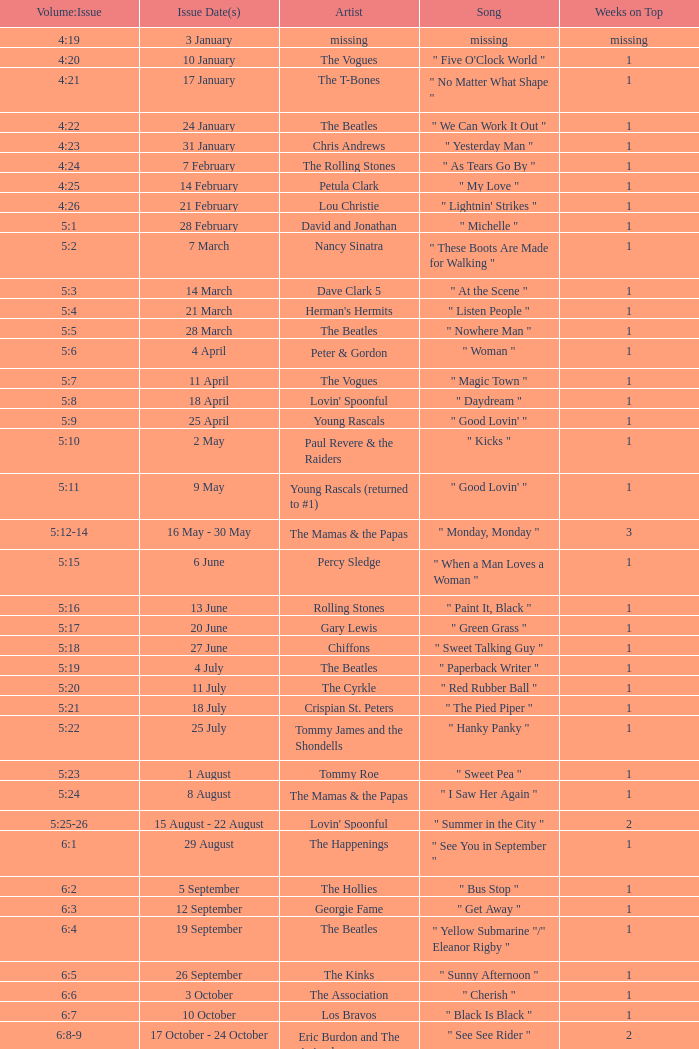With an issue date(s) of 12 September, what is in the column for Weeks on Top? 1.0. 